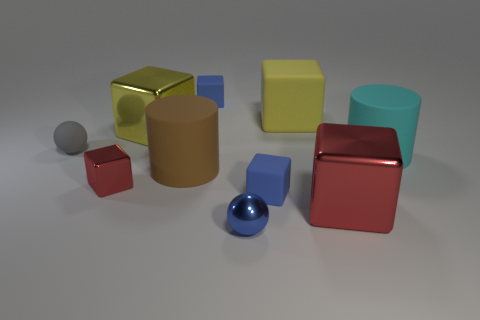Subtract all red blocks. How many blocks are left? 4 Subtract all cyan cylinders. How many cylinders are left? 1 Subtract all cylinders. How many objects are left? 8 Subtract 2 balls. How many balls are left? 0 Subtract all yellow cylinders. Subtract all yellow cubes. How many cylinders are left? 2 Subtract all cyan cylinders. How many cyan balls are left? 0 Subtract all tiny blue spheres. Subtract all metallic balls. How many objects are left? 8 Add 7 big red metal blocks. How many big red metal blocks are left? 8 Add 4 brown matte cylinders. How many brown matte cylinders exist? 5 Subtract 1 gray spheres. How many objects are left? 9 